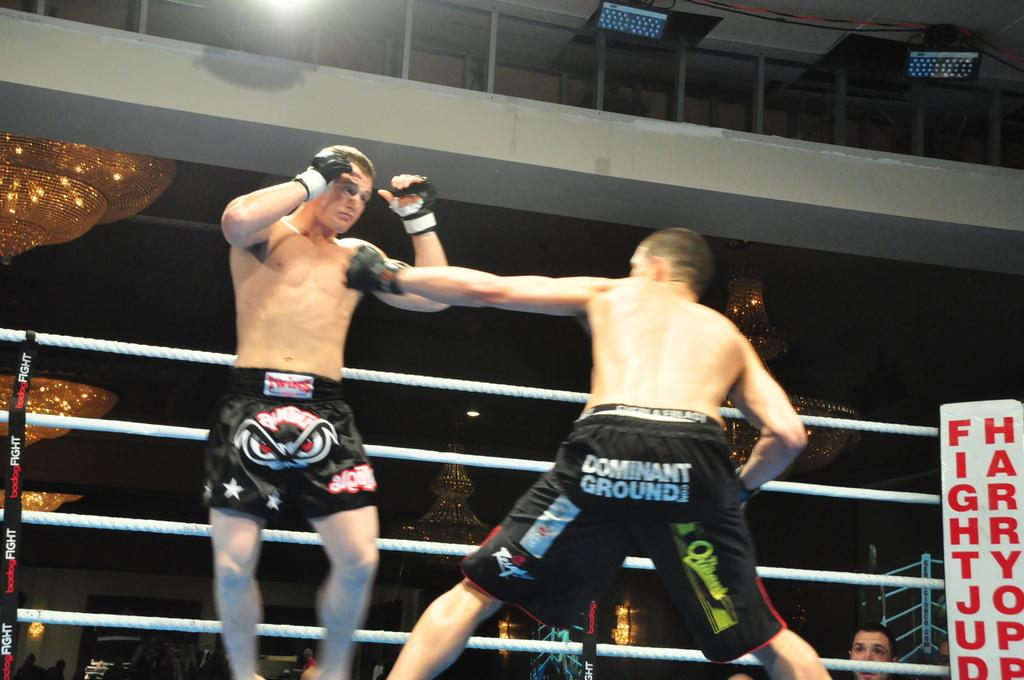<image>
Create a compact narrative representing the image presented. Two fighters fighting one has dominant ground on his butt 